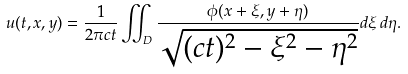<formula> <loc_0><loc_0><loc_500><loc_500>u ( t , x , y ) = { \frac { 1 } { 2 \pi c t } } \iint _ { D } { \frac { \phi ( x + \xi , y + \eta ) } { \sqrt { ( c t ) ^ { 2 } - \xi ^ { 2 } - \eta ^ { 2 } } } } d \xi \, d \eta .</formula> 